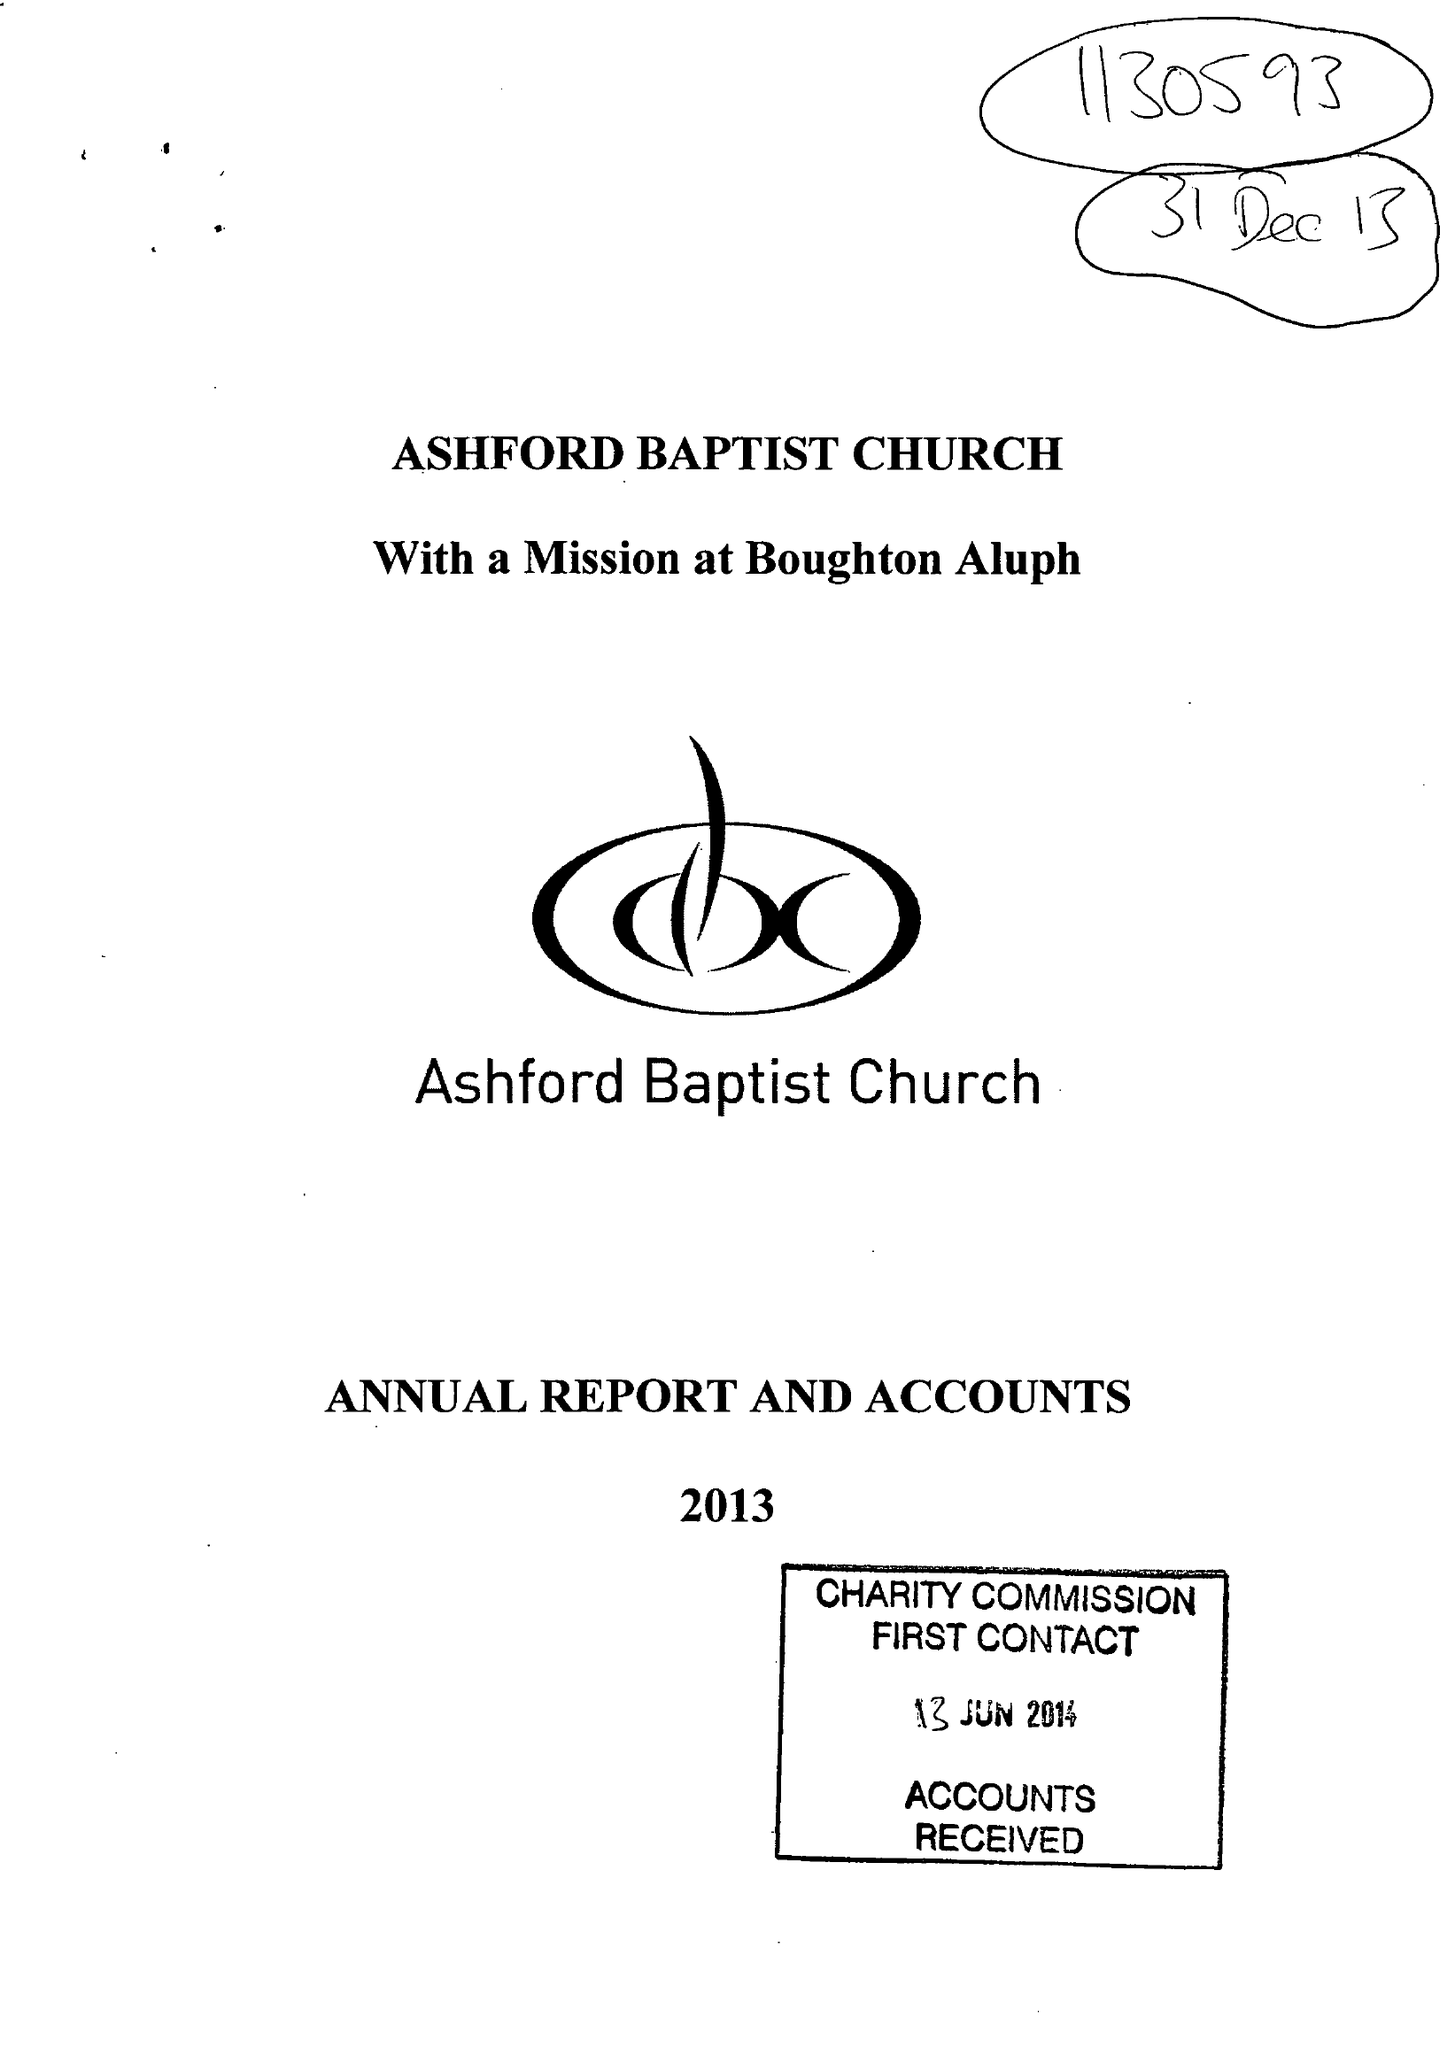What is the value for the spending_annually_in_british_pounds?
Answer the question using a single word or phrase. 178159.00 